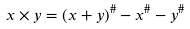<formula> <loc_0><loc_0><loc_500><loc_500>x \times y = ( x + y ) ^ { \# } - x ^ { \# } - y ^ { \# }</formula> 